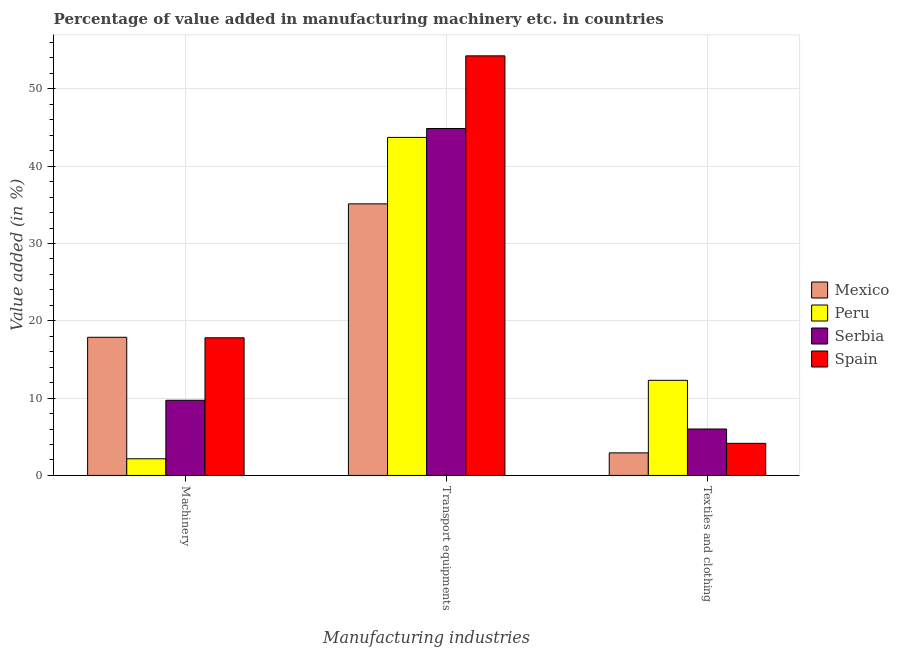Are the number of bars on each tick of the X-axis equal?
Provide a succinct answer. Yes. How many bars are there on the 1st tick from the right?
Provide a succinct answer. 4. What is the label of the 3rd group of bars from the left?
Your answer should be compact. Textiles and clothing. What is the value added in manufacturing textile and clothing in Peru?
Provide a succinct answer. 12.3. Across all countries, what is the maximum value added in manufacturing textile and clothing?
Make the answer very short. 12.3. Across all countries, what is the minimum value added in manufacturing machinery?
Provide a short and direct response. 2.16. What is the total value added in manufacturing textile and clothing in the graph?
Give a very brief answer. 25.38. What is the difference between the value added in manufacturing transport equipments in Mexico and that in Serbia?
Provide a succinct answer. -9.75. What is the difference between the value added in manufacturing machinery in Serbia and the value added in manufacturing textile and clothing in Spain?
Your answer should be compact. 5.57. What is the average value added in manufacturing transport equipments per country?
Keep it short and to the point. 44.5. What is the difference between the value added in manufacturing transport equipments and value added in manufacturing textile and clothing in Spain?
Your answer should be compact. 50.13. In how many countries, is the value added in manufacturing machinery greater than 4 %?
Your answer should be compact. 3. What is the ratio of the value added in manufacturing textile and clothing in Peru to that in Spain?
Make the answer very short. 2.96. Is the value added in manufacturing textile and clothing in Spain less than that in Peru?
Provide a short and direct response. Yes. Is the difference between the value added in manufacturing textile and clothing in Spain and Mexico greater than the difference between the value added in manufacturing machinery in Spain and Mexico?
Your answer should be compact. Yes. What is the difference between the highest and the second highest value added in manufacturing textile and clothing?
Your response must be concise. 6.3. What is the difference between the highest and the lowest value added in manufacturing machinery?
Give a very brief answer. 15.72. In how many countries, is the value added in manufacturing machinery greater than the average value added in manufacturing machinery taken over all countries?
Keep it short and to the point. 2. Is the sum of the value added in manufacturing machinery in Spain and Serbia greater than the maximum value added in manufacturing textile and clothing across all countries?
Offer a terse response. Yes. What does the 3rd bar from the left in Transport equipments represents?
Your answer should be very brief. Serbia. What does the 1st bar from the right in Machinery represents?
Offer a terse response. Spain. Are all the bars in the graph horizontal?
Make the answer very short. No. How many countries are there in the graph?
Ensure brevity in your answer.  4. What is the difference between two consecutive major ticks on the Y-axis?
Offer a very short reply. 10. Are the values on the major ticks of Y-axis written in scientific E-notation?
Provide a succinct answer. No. Does the graph contain any zero values?
Provide a short and direct response. No. Does the graph contain grids?
Provide a succinct answer. Yes. What is the title of the graph?
Your answer should be compact. Percentage of value added in manufacturing machinery etc. in countries. What is the label or title of the X-axis?
Your answer should be compact. Manufacturing industries. What is the label or title of the Y-axis?
Give a very brief answer. Value added (in %). What is the Value added (in %) in Mexico in Machinery?
Give a very brief answer. 17.87. What is the Value added (in %) of Peru in Machinery?
Your answer should be very brief. 2.16. What is the Value added (in %) of Serbia in Machinery?
Keep it short and to the point. 9.72. What is the Value added (in %) of Spain in Machinery?
Provide a succinct answer. 17.81. What is the Value added (in %) in Mexico in Transport equipments?
Your response must be concise. 35.13. What is the Value added (in %) of Peru in Transport equipments?
Make the answer very short. 43.73. What is the Value added (in %) of Serbia in Transport equipments?
Provide a succinct answer. 44.88. What is the Value added (in %) of Spain in Transport equipments?
Your response must be concise. 54.28. What is the Value added (in %) in Mexico in Textiles and clothing?
Make the answer very short. 2.92. What is the Value added (in %) in Peru in Textiles and clothing?
Ensure brevity in your answer.  12.3. What is the Value added (in %) of Serbia in Textiles and clothing?
Keep it short and to the point. 6.01. What is the Value added (in %) in Spain in Textiles and clothing?
Make the answer very short. 4.15. Across all Manufacturing industries, what is the maximum Value added (in %) of Mexico?
Make the answer very short. 35.13. Across all Manufacturing industries, what is the maximum Value added (in %) in Peru?
Provide a succinct answer. 43.73. Across all Manufacturing industries, what is the maximum Value added (in %) in Serbia?
Offer a terse response. 44.88. Across all Manufacturing industries, what is the maximum Value added (in %) in Spain?
Make the answer very short. 54.28. Across all Manufacturing industries, what is the minimum Value added (in %) in Mexico?
Provide a succinct answer. 2.92. Across all Manufacturing industries, what is the minimum Value added (in %) in Peru?
Provide a succinct answer. 2.16. Across all Manufacturing industries, what is the minimum Value added (in %) of Serbia?
Keep it short and to the point. 6.01. Across all Manufacturing industries, what is the minimum Value added (in %) in Spain?
Offer a very short reply. 4.15. What is the total Value added (in %) of Mexico in the graph?
Your answer should be compact. 55.92. What is the total Value added (in %) in Peru in the graph?
Ensure brevity in your answer.  58.19. What is the total Value added (in %) of Serbia in the graph?
Ensure brevity in your answer.  60.61. What is the total Value added (in %) of Spain in the graph?
Give a very brief answer. 76.23. What is the difference between the Value added (in %) in Mexico in Machinery and that in Transport equipments?
Offer a terse response. -17.26. What is the difference between the Value added (in %) of Peru in Machinery and that in Transport equipments?
Offer a very short reply. -41.57. What is the difference between the Value added (in %) in Serbia in Machinery and that in Transport equipments?
Offer a very short reply. -35.16. What is the difference between the Value added (in %) in Spain in Machinery and that in Transport equipments?
Your answer should be very brief. -36.47. What is the difference between the Value added (in %) in Mexico in Machinery and that in Textiles and clothing?
Your answer should be compact. 14.95. What is the difference between the Value added (in %) in Peru in Machinery and that in Textiles and clothing?
Make the answer very short. -10.15. What is the difference between the Value added (in %) of Serbia in Machinery and that in Textiles and clothing?
Provide a succinct answer. 3.72. What is the difference between the Value added (in %) in Spain in Machinery and that in Textiles and clothing?
Ensure brevity in your answer.  13.65. What is the difference between the Value added (in %) of Mexico in Transport equipments and that in Textiles and clothing?
Your answer should be compact. 32.21. What is the difference between the Value added (in %) in Peru in Transport equipments and that in Textiles and clothing?
Provide a short and direct response. 31.42. What is the difference between the Value added (in %) in Serbia in Transport equipments and that in Textiles and clothing?
Offer a very short reply. 38.87. What is the difference between the Value added (in %) of Spain in Transport equipments and that in Textiles and clothing?
Offer a terse response. 50.13. What is the difference between the Value added (in %) in Mexico in Machinery and the Value added (in %) in Peru in Transport equipments?
Make the answer very short. -25.85. What is the difference between the Value added (in %) of Mexico in Machinery and the Value added (in %) of Serbia in Transport equipments?
Give a very brief answer. -27.01. What is the difference between the Value added (in %) in Mexico in Machinery and the Value added (in %) in Spain in Transport equipments?
Provide a succinct answer. -36.4. What is the difference between the Value added (in %) of Peru in Machinery and the Value added (in %) of Serbia in Transport equipments?
Your answer should be very brief. -42.72. What is the difference between the Value added (in %) in Peru in Machinery and the Value added (in %) in Spain in Transport equipments?
Make the answer very short. -52.12. What is the difference between the Value added (in %) of Serbia in Machinery and the Value added (in %) of Spain in Transport equipments?
Offer a terse response. -44.55. What is the difference between the Value added (in %) of Mexico in Machinery and the Value added (in %) of Peru in Textiles and clothing?
Provide a succinct answer. 5.57. What is the difference between the Value added (in %) of Mexico in Machinery and the Value added (in %) of Serbia in Textiles and clothing?
Your answer should be very brief. 11.87. What is the difference between the Value added (in %) in Mexico in Machinery and the Value added (in %) in Spain in Textiles and clothing?
Make the answer very short. 13.72. What is the difference between the Value added (in %) of Peru in Machinery and the Value added (in %) of Serbia in Textiles and clothing?
Keep it short and to the point. -3.85. What is the difference between the Value added (in %) in Peru in Machinery and the Value added (in %) in Spain in Textiles and clothing?
Offer a very short reply. -1.99. What is the difference between the Value added (in %) of Serbia in Machinery and the Value added (in %) of Spain in Textiles and clothing?
Provide a succinct answer. 5.57. What is the difference between the Value added (in %) in Mexico in Transport equipments and the Value added (in %) in Peru in Textiles and clothing?
Give a very brief answer. 22.83. What is the difference between the Value added (in %) in Mexico in Transport equipments and the Value added (in %) in Serbia in Textiles and clothing?
Provide a succinct answer. 29.13. What is the difference between the Value added (in %) of Mexico in Transport equipments and the Value added (in %) of Spain in Textiles and clothing?
Give a very brief answer. 30.98. What is the difference between the Value added (in %) in Peru in Transport equipments and the Value added (in %) in Serbia in Textiles and clothing?
Your response must be concise. 37.72. What is the difference between the Value added (in %) of Peru in Transport equipments and the Value added (in %) of Spain in Textiles and clothing?
Give a very brief answer. 39.58. What is the difference between the Value added (in %) of Serbia in Transport equipments and the Value added (in %) of Spain in Textiles and clothing?
Ensure brevity in your answer.  40.73. What is the average Value added (in %) in Mexico per Manufacturing industries?
Offer a terse response. 18.64. What is the average Value added (in %) in Peru per Manufacturing industries?
Give a very brief answer. 19.4. What is the average Value added (in %) in Serbia per Manufacturing industries?
Your response must be concise. 20.2. What is the average Value added (in %) of Spain per Manufacturing industries?
Your response must be concise. 25.41. What is the difference between the Value added (in %) of Mexico and Value added (in %) of Peru in Machinery?
Offer a very short reply. 15.71. What is the difference between the Value added (in %) in Mexico and Value added (in %) in Serbia in Machinery?
Your response must be concise. 8.15. What is the difference between the Value added (in %) of Mexico and Value added (in %) of Spain in Machinery?
Offer a terse response. 0.07. What is the difference between the Value added (in %) of Peru and Value added (in %) of Serbia in Machinery?
Offer a terse response. -7.57. What is the difference between the Value added (in %) in Peru and Value added (in %) in Spain in Machinery?
Make the answer very short. -15.65. What is the difference between the Value added (in %) in Serbia and Value added (in %) in Spain in Machinery?
Provide a short and direct response. -8.08. What is the difference between the Value added (in %) in Mexico and Value added (in %) in Peru in Transport equipments?
Make the answer very short. -8.6. What is the difference between the Value added (in %) of Mexico and Value added (in %) of Serbia in Transport equipments?
Offer a terse response. -9.75. What is the difference between the Value added (in %) in Mexico and Value added (in %) in Spain in Transport equipments?
Your response must be concise. -19.15. What is the difference between the Value added (in %) of Peru and Value added (in %) of Serbia in Transport equipments?
Keep it short and to the point. -1.15. What is the difference between the Value added (in %) of Peru and Value added (in %) of Spain in Transport equipments?
Your answer should be very brief. -10.55. What is the difference between the Value added (in %) of Serbia and Value added (in %) of Spain in Transport equipments?
Offer a very short reply. -9.4. What is the difference between the Value added (in %) of Mexico and Value added (in %) of Peru in Textiles and clothing?
Your answer should be compact. -9.38. What is the difference between the Value added (in %) in Mexico and Value added (in %) in Serbia in Textiles and clothing?
Provide a succinct answer. -3.09. What is the difference between the Value added (in %) of Mexico and Value added (in %) of Spain in Textiles and clothing?
Offer a very short reply. -1.23. What is the difference between the Value added (in %) of Peru and Value added (in %) of Serbia in Textiles and clothing?
Give a very brief answer. 6.3. What is the difference between the Value added (in %) of Peru and Value added (in %) of Spain in Textiles and clothing?
Provide a succinct answer. 8.15. What is the difference between the Value added (in %) of Serbia and Value added (in %) of Spain in Textiles and clothing?
Your response must be concise. 1.85. What is the ratio of the Value added (in %) of Mexico in Machinery to that in Transport equipments?
Ensure brevity in your answer.  0.51. What is the ratio of the Value added (in %) in Peru in Machinery to that in Transport equipments?
Make the answer very short. 0.05. What is the ratio of the Value added (in %) in Serbia in Machinery to that in Transport equipments?
Provide a short and direct response. 0.22. What is the ratio of the Value added (in %) of Spain in Machinery to that in Transport equipments?
Your answer should be compact. 0.33. What is the ratio of the Value added (in %) of Mexico in Machinery to that in Textiles and clothing?
Give a very brief answer. 6.12. What is the ratio of the Value added (in %) of Peru in Machinery to that in Textiles and clothing?
Your answer should be very brief. 0.18. What is the ratio of the Value added (in %) in Serbia in Machinery to that in Textiles and clothing?
Your response must be concise. 1.62. What is the ratio of the Value added (in %) in Spain in Machinery to that in Textiles and clothing?
Your answer should be very brief. 4.29. What is the ratio of the Value added (in %) of Mexico in Transport equipments to that in Textiles and clothing?
Your response must be concise. 12.03. What is the ratio of the Value added (in %) of Peru in Transport equipments to that in Textiles and clothing?
Keep it short and to the point. 3.55. What is the ratio of the Value added (in %) of Serbia in Transport equipments to that in Textiles and clothing?
Provide a succinct answer. 7.47. What is the ratio of the Value added (in %) in Spain in Transport equipments to that in Textiles and clothing?
Offer a very short reply. 13.07. What is the difference between the highest and the second highest Value added (in %) in Mexico?
Ensure brevity in your answer.  17.26. What is the difference between the highest and the second highest Value added (in %) of Peru?
Ensure brevity in your answer.  31.42. What is the difference between the highest and the second highest Value added (in %) of Serbia?
Give a very brief answer. 35.16. What is the difference between the highest and the second highest Value added (in %) in Spain?
Your answer should be compact. 36.47. What is the difference between the highest and the lowest Value added (in %) of Mexico?
Give a very brief answer. 32.21. What is the difference between the highest and the lowest Value added (in %) of Peru?
Keep it short and to the point. 41.57. What is the difference between the highest and the lowest Value added (in %) in Serbia?
Give a very brief answer. 38.87. What is the difference between the highest and the lowest Value added (in %) of Spain?
Offer a very short reply. 50.13. 